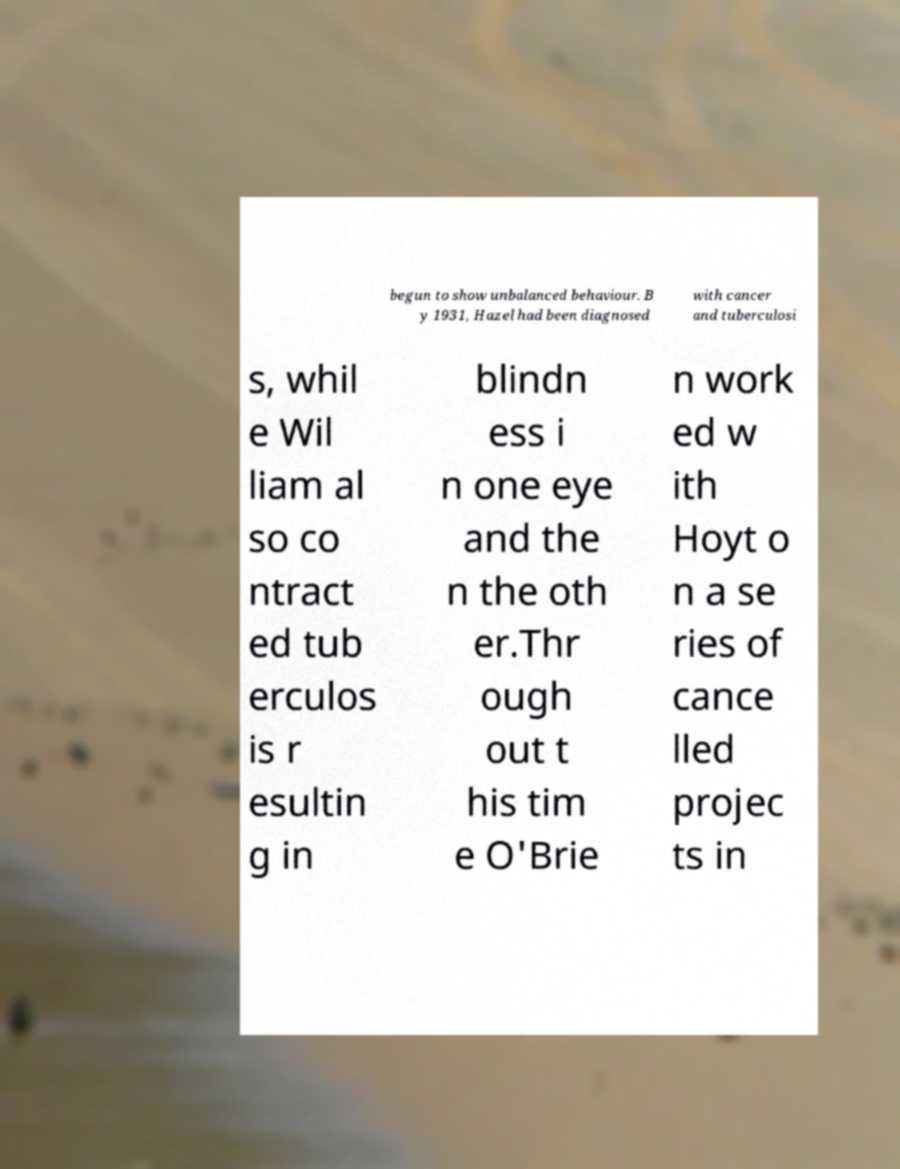Please read and relay the text visible in this image. What does it say? begun to show unbalanced behaviour. B y 1931, Hazel had been diagnosed with cancer and tuberculosi s, whil e Wil liam al so co ntract ed tub erculos is r esultin g in blindn ess i n one eye and the n the oth er.Thr ough out t his tim e O'Brie n work ed w ith Hoyt o n a se ries of cance lled projec ts in 